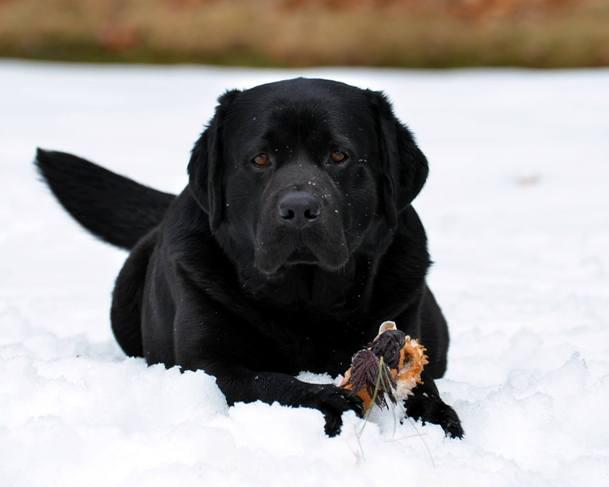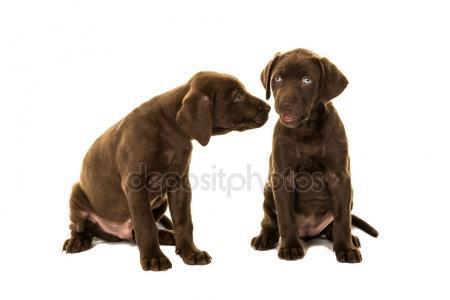The first image is the image on the left, the second image is the image on the right. For the images displayed, is the sentence "One image shows a single black dog and the other shows a pair of brown dogs." factually correct? Answer yes or no. Yes. The first image is the image on the left, the second image is the image on the right. For the images displayed, is the sentence "At least one dog has its tongue out." factually correct? Answer yes or no. No. 